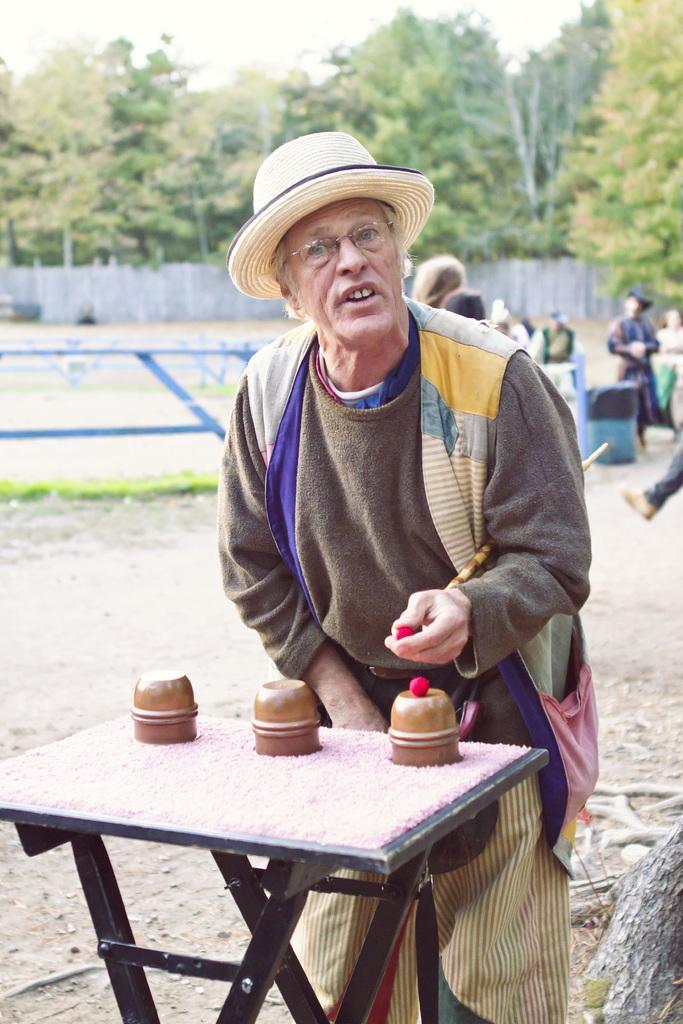Please provide a concise description of this image. An old man is showing a magic trick with red balls and cups. 